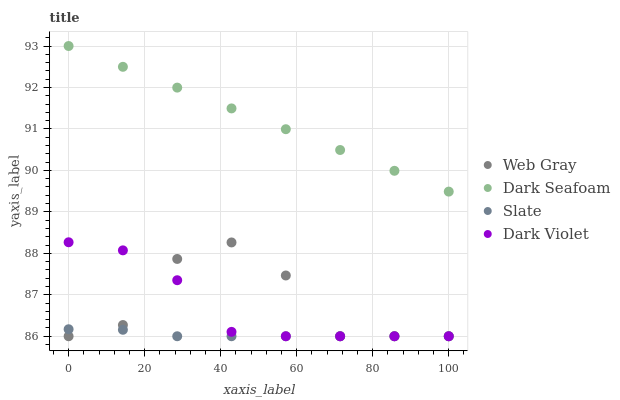Does Slate have the minimum area under the curve?
Answer yes or no. Yes. Does Dark Seafoam have the maximum area under the curve?
Answer yes or no. Yes. Does Web Gray have the minimum area under the curve?
Answer yes or no. No. Does Web Gray have the maximum area under the curve?
Answer yes or no. No. Is Dark Seafoam the smoothest?
Answer yes or no. Yes. Is Web Gray the roughest?
Answer yes or no. Yes. Is Slate the smoothest?
Answer yes or no. No. Is Slate the roughest?
Answer yes or no. No. Does Web Gray have the lowest value?
Answer yes or no. Yes. Does Dark Seafoam have the highest value?
Answer yes or no. Yes. Does Web Gray have the highest value?
Answer yes or no. No. Is Web Gray less than Dark Seafoam?
Answer yes or no. Yes. Is Dark Seafoam greater than Slate?
Answer yes or no. Yes. Does Dark Violet intersect Slate?
Answer yes or no. Yes. Is Dark Violet less than Slate?
Answer yes or no. No. Is Dark Violet greater than Slate?
Answer yes or no. No. Does Web Gray intersect Dark Seafoam?
Answer yes or no. No. 